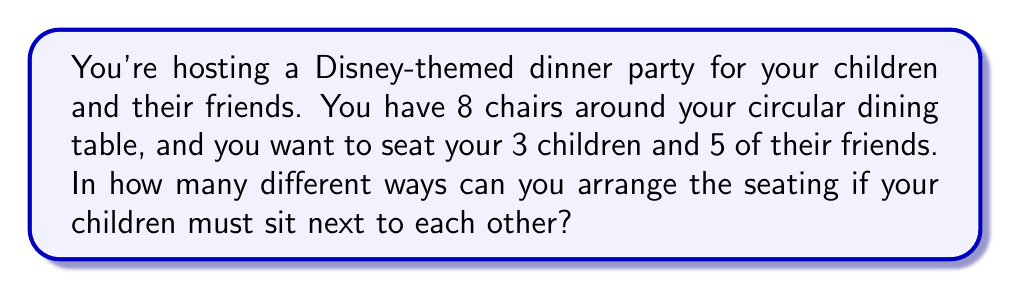What is the answer to this math problem? Let's approach this step-by-step:

1) First, we need to consider your 3 children as one unit, since they must sit together. This effectively reduces our problem to arranging 6 units (the children unit and the 5 friends) around the circular table.

2) For circular arrangements, we use the formula:
   $$(n-1)!$$
   where $n$ is the number of items being arranged.

3) In this case, $n = 6$ (5 friends + 1 children unit). So we have:
   $$(6-1)! = 5! = 5 \times 4 \times 3 \times 2 \times 1 = 120$$

4) However, we're not done yet. We also need to consider the different ways your 3 children can be arranged within their unit.

5) The number of ways to arrange 3 children is simply $3! = 3 \times 2 \times 1 = 6$

6) By the multiplication principle, we multiply these results:
   $$120 \times 6 = 720$$

Therefore, there are 720 different ways to arrange the seating.
Answer: 720 different seating arrangements 